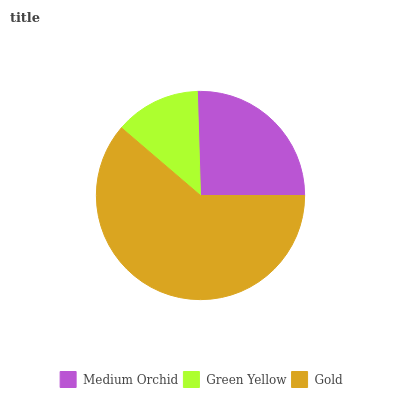Is Green Yellow the minimum?
Answer yes or no. Yes. Is Gold the maximum?
Answer yes or no. Yes. Is Gold the minimum?
Answer yes or no. No. Is Green Yellow the maximum?
Answer yes or no. No. Is Gold greater than Green Yellow?
Answer yes or no. Yes. Is Green Yellow less than Gold?
Answer yes or no. Yes. Is Green Yellow greater than Gold?
Answer yes or no. No. Is Gold less than Green Yellow?
Answer yes or no. No. Is Medium Orchid the high median?
Answer yes or no. Yes. Is Medium Orchid the low median?
Answer yes or no. Yes. Is Green Yellow the high median?
Answer yes or no. No. Is Gold the low median?
Answer yes or no. No. 